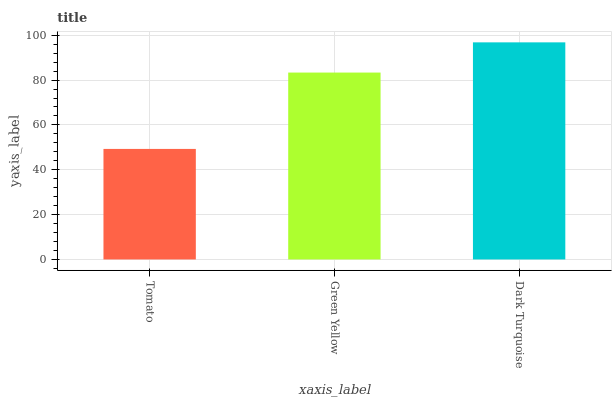Is Tomato the minimum?
Answer yes or no. Yes. Is Dark Turquoise the maximum?
Answer yes or no. Yes. Is Green Yellow the minimum?
Answer yes or no. No. Is Green Yellow the maximum?
Answer yes or no. No. Is Green Yellow greater than Tomato?
Answer yes or no. Yes. Is Tomato less than Green Yellow?
Answer yes or no. Yes. Is Tomato greater than Green Yellow?
Answer yes or no. No. Is Green Yellow less than Tomato?
Answer yes or no. No. Is Green Yellow the high median?
Answer yes or no. Yes. Is Green Yellow the low median?
Answer yes or no. Yes. Is Tomato the high median?
Answer yes or no. No. Is Tomato the low median?
Answer yes or no. No. 